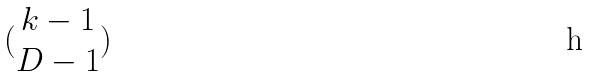Convert formula to latex. <formula><loc_0><loc_0><loc_500><loc_500>( \begin{matrix} k - 1 \\ D - 1 \end{matrix} )</formula> 